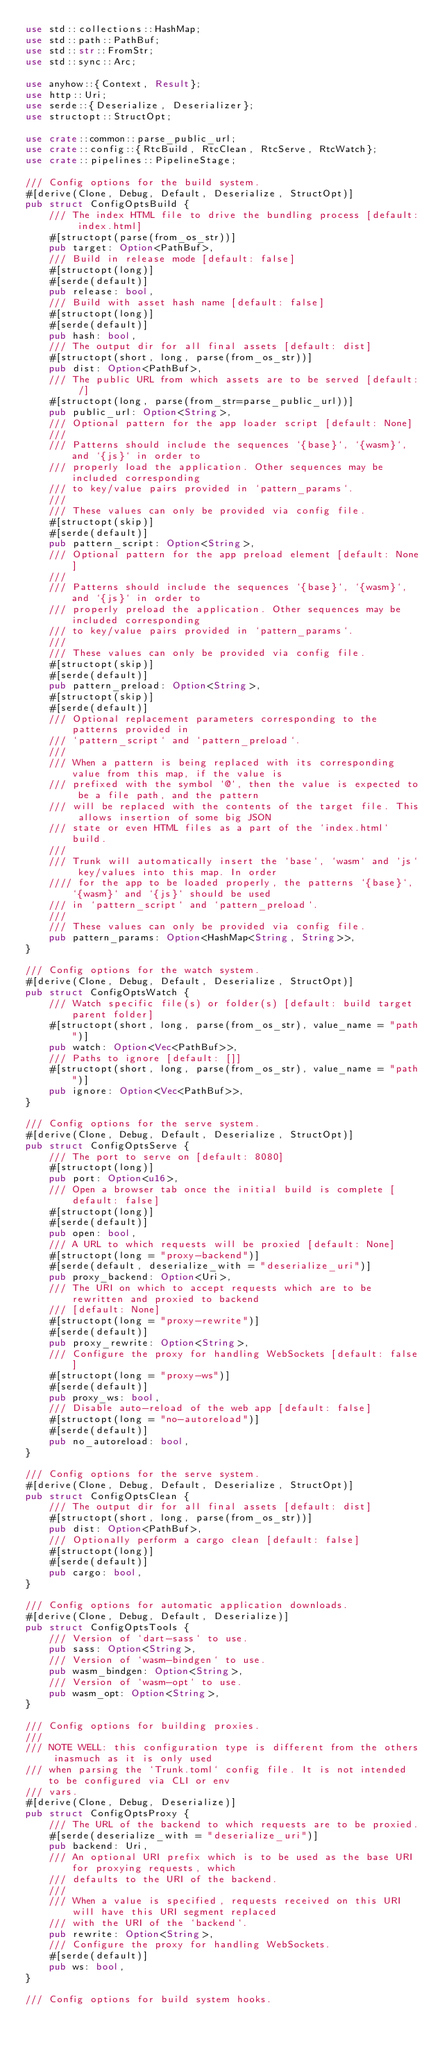Convert code to text. <code><loc_0><loc_0><loc_500><loc_500><_Rust_>use std::collections::HashMap;
use std::path::PathBuf;
use std::str::FromStr;
use std::sync::Arc;

use anyhow::{Context, Result};
use http::Uri;
use serde::{Deserialize, Deserializer};
use structopt::StructOpt;

use crate::common::parse_public_url;
use crate::config::{RtcBuild, RtcClean, RtcServe, RtcWatch};
use crate::pipelines::PipelineStage;

/// Config options for the build system.
#[derive(Clone, Debug, Default, Deserialize, StructOpt)]
pub struct ConfigOptsBuild {
    /// The index HTML file to drive the bundling process [default: index.html]
    #[structopt(parse(from_os_str))]
    pub target: Option<PathBuf>,
    /// Build in release mode [default: false]
    #[structopt(long)]
    #[serde(default)]
    pub release: bool,
    /// Build with asset hash name [default: false]
    #[structopt(long)]
    #[serde(default)]
    pub hash: bool,
    /// The output dir for all final assets [default: dist]
    #[structopt(short, long, parse(from_os_str))]
    pub dist: Option<PathBuf>,
    /// The public URL from which assets are to be served [default: /]
    #[structopt(long, parse(from_str=parse_public_url))]
    pub public_url: Option<String>,
    /// Optional pattern for the app loader script [default: None]
    ///
    /// Patterns should include the sequences `{base}`, `{wasm}`, and `{js}` in order to
    /// properly load the application. Other sequences may be included corresponding
    /// to key/value pairs provided in `pattern_params`.
    ///
    /// These values can only be provided via config file.
    #[structopt(skip)]
    #[serde(default)]
    pub pattern_script: Option<String>,
    /// Optional pattern for the app preload element [default: None]
    ///
    /// Patterns should include the sequences `{base}`, `{wasm}`, and `{js}` in order to
    /// properly preload the application. Other sequences may be included corresponding
    /// to key/value pairs provided in `pattern_params`.
    ///
    /// These values can only be provided via config file.
    #[structopt(skip)]
    #[serde(default)]
    pub pattern_preload: Option<String>,
    #[structopt(skip)]
    #[serde(default)]
    /// Optional replacement parameters corresponding to the patterns provided in
    /// `pattern_script` and `pattern_preload`.
    ///
    /// When a pattern is being replaced with its corresponding value from this map, if the value is
    /// prefixed with the symbol `@`, then the value is expected to be a file path, and the pattern
    /// will be replaced with the contents of the target file. This allows insertion of some big JSON
    /// state or even HTML files as a part of the `index.html` build.
    ///
    /// Trunk will automatically insert the `base`, `wasm` and `js` key/values into this map. In order
    //// for the app to be loaded properly, the patterns `{base}`, `{wasm}` and `{js}` should be used
    /// in `pattern_script` and `pattern_preload`.
    ///
    /// These values can only be provided via config file.
    pub pattern_params: Option<HashMap<String, String>>,
}

/// Config options for the watch system.
#[derive(Clone, Debug, Default, Deserialize, StructOpt)]
pub struct ConfigOptsWatch {
    /// Watch specific file(s) or folder(s) [default: build target parent folder]
    #[structopt(short, long, parse(from_os_str), value_name = "path")]
    pub watch: Option<Vec<PathBuf>>,
    /// Paths to ignore [default: []]
    #[structopt(short, long, parse(from_os_str), value_name = "path")]
    pub ignore: Option<Vec<PathBuf>>,
}

/// Config options for the serve system.
#[derive(Clone, Debug, Default, Deserialize, StructOpt)]
pub struct ConfigOptsServe {
    /// The port to serve on [default: 8080]
    #[structopt(long)]
    pub port: Option<u16>,
    /// Open a browser tab once the initial build is complete [default: false]
    #[structopt(long)]
    #[serde(default)]
    pub open: bool,
    /// A URL to which requests will be proxied [default: None]
    #[structopt(long = "proxy-backend")]
    #[serde(default, deserialize_with = "deserialize_uri")]
    pub proxy_backend: Option<Uri>,
    /// The URI on which to accept requests which are to be rewritten and proxied to backend
    /// [default: None]
    #[structopt(long = "proxy-rewrite")]
    #[serde(default)]
    pub proxy_rewrite: Option<String>,
    /// Configure the proxy for handling WebSockets [default: false]
    #[structopt(long = "proxy-ws")]
    #[serde(default)]
    pub proxy_ws: bool,
    /// Disable auto-reload of the web app [default: false]
    #[structopt(long = "no-autoreload")]
    #[serde(default)]
    pub no_autoreload: bool,
}

/// Config options for the serve system.
#[derive(Clone, Debug, Default, Deserialize, StructOpt)]
pub struct ConfigOptsClean {
    /// The output dir for all final assets [default: dist]
    #[structopt(short, long, parse(from_os_str))]
    pub dist: Option<PathBuf>,
    /// Optionally perform a cargo clean [default: false]
    #[structopt(long)]
    #[serde(default)]
    pub cargo: bool,
}

/// Config options for automatic application downloads.
#[derive(Clone, Debug, Default, Deserialize)]
pub struct ConfigOptsTools {
    /// Version of `dart-sass` to use.
    pub sass: Option<String>,
    /// Version of `wasm-bindgen` to use.
    pub wasm_bindgen: Option<String>,
    /// Version of `wasm-opt` to use.
    pub wasm_opt: Option<String>,
}

/// Config options for building proxies.
///
/// NOTE WELL: this configuration type is different from the others inasmuch as it is only used
/// when parsing the `Trunk.toml` config file. It is not intended to be configured via CLI or env
/// vars.
#[derive(Clone, Debug, Deserialize)]
pub struct ConfigOptsProxy {
    /// The URL of the backend to which requests are to be proxied.
    #[serde(deserialize_with = "deserialize_uri")]
    pub backend: Uri,
    /// An optional URI prefix which is to be used as the base URI for proxying requests, which
    /// defaults to the URI of the backend.
    ///
    /// When a value is specified, requests received on this URI will have this URI segment replaced
    /// with the URI of the `backend`.
    pub rewrite: Option<String>,
    /// Configure the proxy for handling WebSockets.
    #[serde(default)]
    pub ws: bool,
}

/// Config options for build system hooks.</code> 